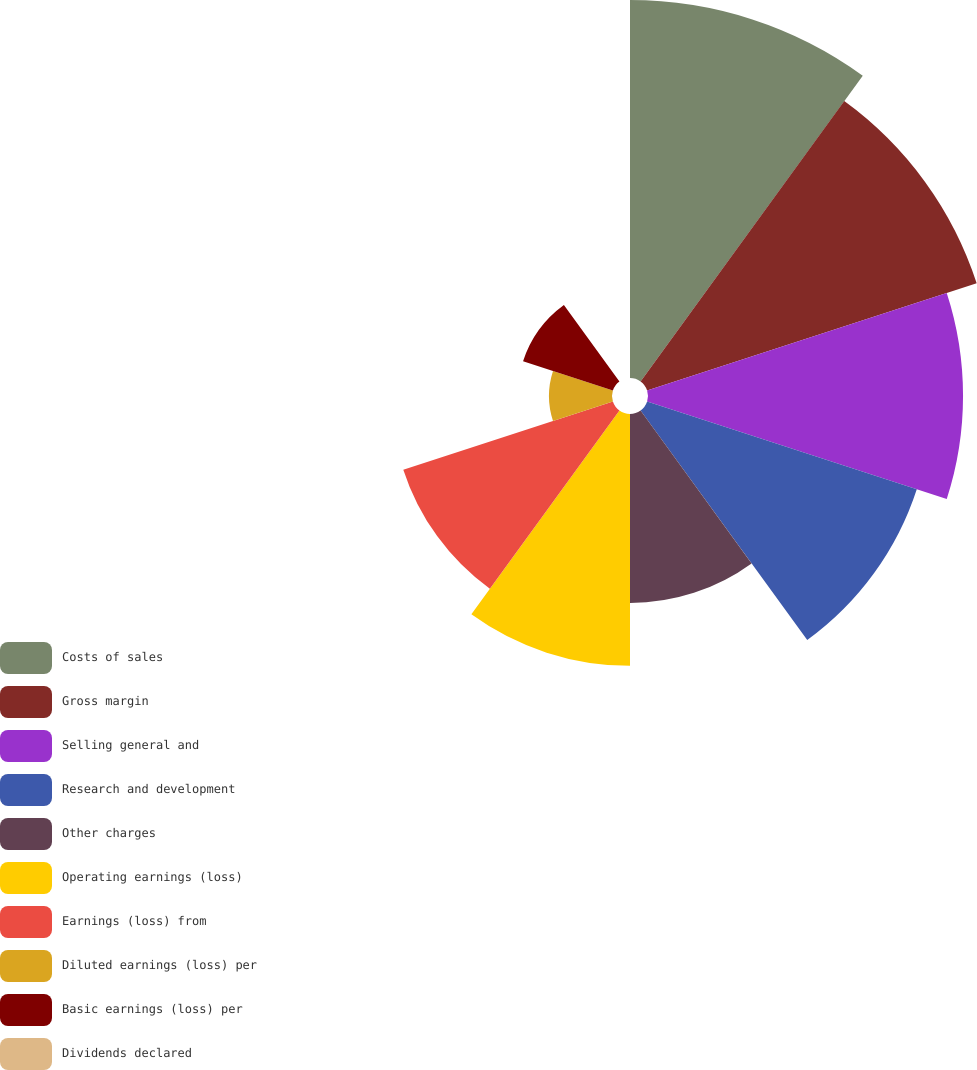Convert chart to OTSL. <chart><loc_0><loc_0><loc_500><loc_500><pie_chart><fcel>Costs of sales<fcel>Gross margin<fcel>Selling general and<fcel>Research and development<fcel>Other charges<fcel>Operating earnings (loss)<fcel>Earnings (loss) from<fcel>Diluted earnings (loss) per<fcel>Basic earnings (loss) per<fcel>Dividends declared<nl><fcel>17.65%<fcel>16.18%<fcel>14.71%<fcel>13.24%<fcel>8.82%<fcel>11.76%<fcel>10.29%<fcel>2.94%<fcel>4.41%<fcel>0.0%<nl></chart> 